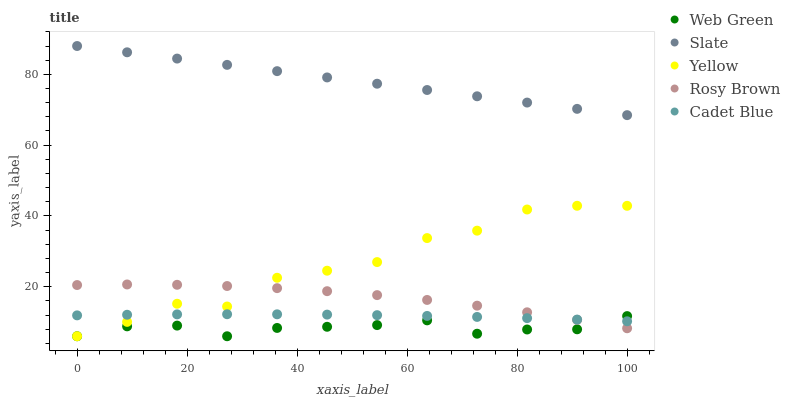Does Web Green have the minimum area under the curve?
Answer yes or no. Yes. Does Slate have the maximum area under the curve?
Answer yes or no. Yes. Does Rosy Brown have the minimum area under the curve?
Answer yes or no. No. Does Rosy Brown have the maximum area under the curve?
Answer yes or no. No. Is Slate the smoothest?
Answer yes or no. Yes. Is Yellow the roughest?
Answer yes or no. Yes. Is Rosy Brown the smoothest?
Answer yes or no. No. Is Rosy Brown the roughest?
Answer yes or no. No. Does Yellow have the lowest value?
Answer yes or no. Yes. Does Rosy Brown have the lowest value?
Answer yes or no. No. Does Slate have the highest value?
Answer yes or no. Yes. Does Rosy Brown have the highest value?
Answer yes or no. No. Is Cadet Blue less than Slate?
Answer yes or no. Yes. Is Slate greater than Web Green?
Answer yes or no. Yes. Does Web Green intersect Yellow?
Answer yes or no. Yes. Is Web Green less than Yellow?
Answer yes or no. No. Is Web Green greater than Yellow?
Answer yes or no. No. Does Cadet Blue intersect Slate?
Answer yes or no. No. 